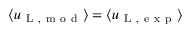Convert formula to latex. <formula><loc_0><loc_0><loc_500><loc_500>\langle u _ { L , m o d } \rangle = \langle u _ { L , e x p } \rangle</formula> 